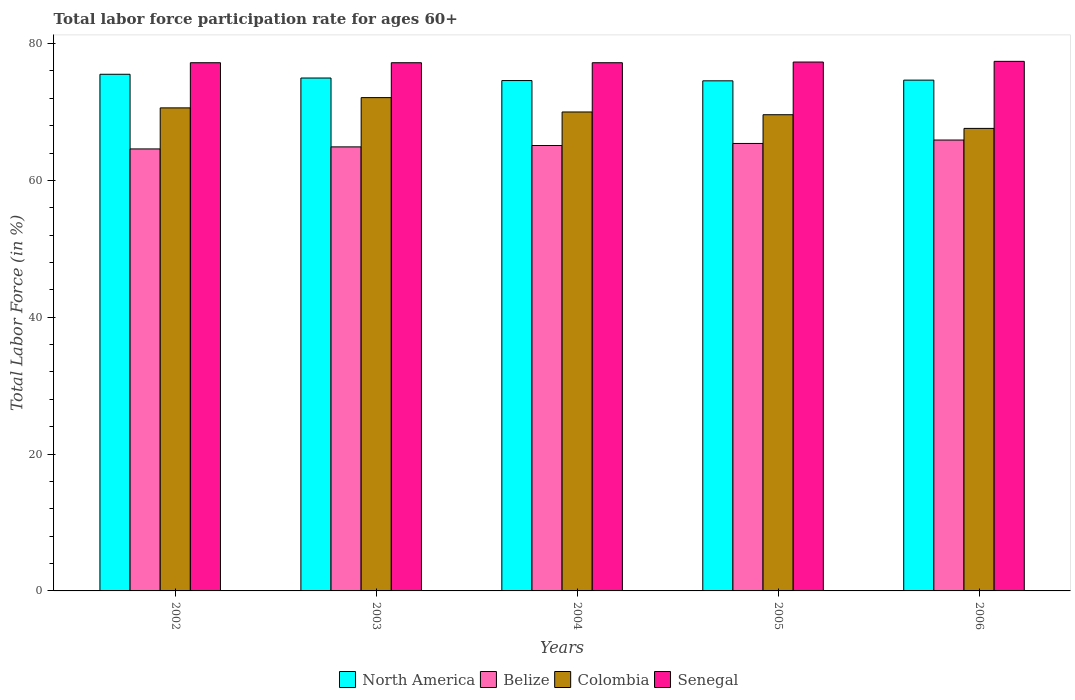How many groups of bars are there?
Your answer should be compact. 5. How many bars are there on the 4th tick from the right?
Make the answer very short. 4. What is the label of the 3rd group of bars from the left?
Give a very brief answer. 2004. What is the labor force participation rate in Senegal in 2002?
Your answer should be very brief. 77.2. Across all years, what is the maximum labor force participation rate in Colombia?
Provide a succinct answer. 72.1. Across all years, what is the minimum labor force participation rate in Colombia?
Offer a terse response. 67.6. What is the total labor force participation rate in Belize in the graph?
Your answer should be very brief. 325.9. What is the difference between the labor force participation rate in Colombia in 2003 and that in 2005?
Your answer should be compact. 2.5. What is the difference between the labor force participation rate in Belize in 2003 and the labor force participation rate in Senegal in 2005?
Your answer should be very brief. -12.4. What is the average labor force participation rate in Senegal per year?
Make the answer very short. 77.26. In the year 2003, what is the difference between the labor force participation rate in Belize and labor force participation rate in Senegal?
Make the answer very short. -12.3. What is the ratio of the labor force participation rate in Belize in 2002 to that in 2003?
Provide a short and direct response. 1. Is the difference between the labor force participation rate in Belize in 2003 and 2004 greater than the difference between the labor force participation rate in Senegal in 2003 and 2004?
Make the answer very short. No. What is the difference between the highest and the second highest labor force participation rate in Senegal?
Provide a short and direct response. 0.1. What is the difference between the highest and the lowest labor force participation rate in Senegal?
Your response must be concise. 0.2. What does the 3rd bar from the left in 2004 represents?
Provide a succinct answer. Colombia. How many bars are there?
Give a very brief answer. 20. How many years are there in the graph?
Give a very brief answer. 5. What is the difference between two consecutive major ticks on the Y-axis?
Ensure brevity in your answer.  20. Are the values on the major ticks of Y-axis written in scientific E-notation?
Offer a very short reply. No. Does the graph contain grids?
Give a very brief answer. No. Where does the legend appear in the graph?
Provide a short and direct response. Bottom center. How are the legend labels stacked?
Your answer should be compact. Horizontal. What is the title of the graph?
Your answer should be compact. Total labor force participation rate for ages 60+. Does "Malta" appear as one of the legend labels in the graph?
Make the answer very short. No. What is the label or title of the X-axis?
Offer a terse response. Years. What is the Total Labor Force (in %) of North America in 2002?
Ensure brevity in your answer.  75.51. What is the Total Labor Force (in %) in Belize in 2002?
Keep it short and to the point. 64.6. What is the Total Labor Force (in %) in Colombia in 2002?
Offer a very short reply. 70.6. What is the Total Labor Force (in %) of Senegal in 2002?
Keep it short and to the point. 77.2. What is the Total Labor Force (in %) of North America in 2003?
Offer a very short reply. 74.96. What is the Total Labor Force (in %) of Belize in 2003?
Your answer should be compact. 64.9. What is the Total Labor Force (in %) of Colombia in 2003?
Your answer should be very brief. 72.1. What is the Total Labor Force (in %) in Senegal in 2003?
Your answer should be very brief. 77.2. What is the Total Labor Force (in %) in North America in 2004?
Your response must be concise. 74.59. What is the Total Labor Force (in %) in Belize in 2004?
Offer a terse response. 65.1. What is the Total Labor Force (in %) in Senegal in 2004?
Make the answer very short. 77.2. What is the Total Labor Force (in %) in North America in 2005?
Make the answer very short. 74.55. What is the Total Labor Force (in %) in Belize in 2005?
Make the answer very short. 65.4. What is the Total Labor Force (in %) of Colombia in 2005?
Your response must be concise. 69.6. What is the Total Labor Force (in %) of Senegal in 2005?
Offer a terse response. 77.3. What is the Total Labor Force (in %) in North America in 2006?
Your response must be concise. 74.65. What is the Total Labor Force (in %) of Belize in 2006?
Ensure brevity in your answer.  65.9. What is the Total Labor Force (in %) in Colombia in 2006?
Offer a very short reply. 67.6. What is the Total Labor Force (in %) in Senegal in 2006?
Keep it short and to the point. 77.4. Across all years, what is the maximum Total Labor Force (in %) in North America?
Your response must be concise. 75.51. Across all years, what is the maximum Total Labor Force (in %) of Belize?
Provide a short and direct response. 65.9. Across all years, what is the maximum Total Labor Force (in %) in Colombia?
Give a very brief answer. 72.1. Across all years, what is the maximum Total Labor Force (in %) in Senegal?
Provide a succinct answer. 77.4. Across all years, what is the minimum Total Labor Force (in %) in North America?
Make the answer very short. 74.55. Across all years, what is the minimum Total Labor Force (in %) of Belize?
Your answer should be compact. 64.6. Across all years, what is the minimum Total Labor Force (in %) of Colombia?
Your answer should be very brief. 67.6. Across all years, what is the minimum Total Labor Force (in %) in Senegal?
Your answer should be compact. 77.2. What is the total Total Labor Force (in %) in North America in the graph?
Your answer should be compact. 374.28. What is the total Total Labor Force (in %) of Belize in the graph?
Provide a succinct answer. 325.9. What is the total Total Labor Force (in %) in Colombia in the graph?
Offer a terse response. 349.9. What is the total Total Labor Force (in %) of Senegal in the graph?
Your response must be concise. 386.3. What is the difference between the Total Labor Force (in %) of North America in 2002 and that in 2003?
Ensure brevity in your answer.  0.55. What is the difference between the Total Labor Force (in %) in Belize in 2002 and that in 2003?
Your answer should be compact. -0.3. What is the difference between the Total Labor Force (in %) in Senegal in 2002 and that in 2003?
Your answer should be compact. 0. What is the difference between the Total Labor Force (in %) in North America in 2002 and that in 2004?
Give a very brief answer. 0.92. What is the difference between the Total Labor Force (in %) of Colombia in 2002 and that in 2004?
Your answer should be very brief. 0.6. What is the difference between the Total Labor Force (in %) of Senegal in 2002 and that in 2004?
Provide a succinct answer. 0. What is the difference between the Total Labor Force (in %) of North America in 2002 and that in 2005?
Offer a very short reply. 0.96. What is the difference between the Total Labor Force (in %) of Belize in 2002 and that in 2005?
Give a very brief answer. -0.8. What is the difference between the Total Labor Force (in %) of Colombia in 2002 and that in 2005?
Ensure brevity in your answer.  1. What is the difference between the Total Labor Force (in %) in North America in 2002 and that in 2006?
Provide a succinct answer. 0.86. What is the difference between the Total Labor Force (in %) of Colombia in 2002 and that in 2006?
Make the answer very short. 3. What is the difference between the Total Labor Force (in %) in Senegal in 2002 and that in 2006?
Your answer should be very brief. -0.2. What is the difference between the Total Labor Force (in %) of North America in 2003 and that in 2004?
Offer a very short reply. 0.37. What is the difference between the Total Labor Force (in %) in Colombia in 2003 and that in 2004?
Your response must be concise. 2.1. What is the difference between the Total Labor Force (in %) of Senegal in 2003 and that in 2004?
Your response must be concise. 0. What is the difference between the Total Labor Force (in %) of North America in 2003 and that in 2005?
Provide a short and direct response. 0.41. What is the difference between the Total Labor Force (in %) of Belize in 2003 and that in 2005?
Your answer should be very brief. -0.5. What is the difference between the Total Labor Force (in %) in Colombia in 2003 and that in 2005?
Give a very brief answer. 2.5. What is the difference between the Total Labor Force (in %) in North America in 2003 and that in 2006?
Ensure brevity in your answer.  0.31. What is the difference between the Total Labor Force (in %) in Belize in 2003 and that in 2006?
Give a very brief answer. -1. What is the difference between the Total Labor Force (in %) in North America in 2004 and that in 2005?
Keep it short and to the point. 0.04. What is the difference between the Total Labor Force (in %) in North America in 2004 and that in 2006?
Your response must be concise. -0.06. What is the difference between the Total Labor Force (in %) of Belize in 2004 and that in 2006?
Your answer should be very brief. -0.8. What is the difference between the Total Labor Force (in %) of North America in 2005 and that in 2006?
Make the answer very short. -0.1. What is the difference between the Total Labor Force (in %) of Belize in 2005 and that in 2006?
Provide a succinct answer. -0.5. What is the difference between the Total Labor Force (in %) in North America in 2002 and the Total Labor Force (in %) in Belize in 2003?
Your answer should be very brief. 10.61. What is the difference between the Total Labor Force (in %) in North America in 2002 and the Total Labor Force (in %) in Colombia in 2003?
Your answer should be compact. 3.41. What is the difference between the Total Labor Force (in %) in North America in 2002 and the Total Labor Force (in %) in Senegal in 2003?
Your answer should be compact. -1.69. What is the difference between the Total Labor Force (in %) of Colombia in 2002 and the Total Labor Force (in %) of Senegal in 2003?
Give a very brief answer. -6.6. What is the difference between the Total Labor Force (in %) in North America in 2002 and the Total Labor Force (in %) in Belize in 2004?
Offer a very short reply. 10.41. What is the difference between the Total Labor Force (in %) of North America in 2002 and the Total Labor Force (in %) of Colombia in 2004?
Make the answer very short. 5.51. What is the difference between the Total Labor Force (in %) in North America in 2002 and the Total Labor Force (in %) in Senegal in 2004?
Keep it short and to the point. -1.69. What is the difference between the Total Labor Force (in %) in North America in 2002 and the Total Labor Force (in %) in Belize in 2005?
Offer a very short reply. 10.11. What is the difference between the Total Labor Force (in %) in North America in 2002 and the Total Labor Force (in %) in Colombia in 2005?
Ensure brevity in your answer.  5.91. What is the difference between the Total Labor Force (in %) in North America in 2002 and the Total Labor Force (in %) in Senegal in 2005?
Your response must be concise. -1.79. What is the difference between the Total Labor Force (in %) of Belize in 2002 and the Total Labor Force (in %) of Colombia in 2005?
Keep it short and to the point. -5. What is the difference between the Total Labor Force (in %) in Belize in 2002 and the Total Labor Force (in %) in Senegal in 2005?
Offer a very short reply. -12.7. What is the difference between the Total Labor Force (in %) of Colombia in 2002 and the Total Labor Force (in %) of Senegal in 2005?
Provide a succinct answer. -6.7. What is the difference between the Total Labor Force (in %) in North America in 2002 and the Total Labor Force (in %) in Belize in 2006?
Your answer should be compact. 9.61. What is the difference between the Total Labor Force (in %) of North America in 2002 and the Total Labor Force (in %) of Colombia in 2006?
Ensure brevity in your answer.  7.91. What is the difference between the Total Labor Force (in %) in North America in 2002 and the Total Labor Force (in %) in Senegal in 2006?
Your answer should be compact. -1.89. What is the difference between the Total Labor Force (in %) of Belize in 2002 and the Total Labor Force (in %) of Colombia in 2006?
Your response must be concise. -3. What is the difference between the Total Labor Force (in %) of Belize in 2002 and the Total Labor Force (in %) of Senegal in 2006?
Offer a terse response. -12.8. What is the difference between the Total Labor Force (in %) of North America in 2003 and the Total Labor Force (in %) of Belize in 2004?
Ensure brevity in your answer.  9.86. What is the difference between the Total Labor Force (in %) in North America in 2003 and the Total Labor Force (in %) in Colombia in 2004?
Offer a very short reply. 4.96. What is the difference between the Total Labor Force (in %) of North America in 2003 and the Total Labor Force (in %) of Senegal in 2004?
Keep it short and to the point. -2.24. What is the difference between the Total Labor Force (in %) in Belize in 2003 and the Total Labor Force (in %) in Colombia in 2004?
Give a very brief answer. -5.1. What is the difference between the Total Labor Force (in %) of Colombia in 2003 and the Total Labor Force (in %) of Senegal in 2004?
Ensure brevity in your answer.  -5.1. What is the difference between the Total Labor Force (in %) of North America in 2003 and the Total Labor Force (in %) of Belize in 2005?
Provide a succinct answer. 9.56. What is the difference between the Total Labor Force (in %) of North America in 2003 and the Total Labor Force (in %) of Colombia in 2005?
Your answer should be very brief. 5.36. What is the difference between the Total Labor Force (in %) in North America in 2003 and the Total Labor Force (in %) in Senegal in 2005?
Your answer should be very brief. -2.34. What is the difference between the Total Labor Force (in %) in Belize in 2003 and the Total Labor Force (in %) in Colombia in 2005?
Offer a terse response. -4.7. What is the difference between the Total Labor Force (in %) in Colombia in 2003 and the Total Labor Force (in %) in Senegal in 2005?
Give a very brief answer. -5.2. What is the difference between the Total Labor Force (in %) of North America in 2003 and the Total Labor Force (in %) of Belize in 2006?
Keep it short and to the point. 9.06. What is the difference between the Total Labor Force (in %) of North America in 2003 and the Total Labor Force (in %) of Colombia in 2006?
Make the answer very short. 7.36. What is the difference between the Total Labor Force (in %) in North America in 2003 and the Total Labor Force (in %) in Senegal in 2006?
Give a very brief answer. -2.44. What is the difference between the Total Labor Force (in %) in Belize in 2003 and the Total Labor Force (in %) in Colombia in 2006?
Offer a very short reply. -2.7. What is the difference between the Total Labor Force (in %) in Belize in 2003 and the Total Labor Force (in %) in Senegal in 2006?
Your answer should be very brief. -12.5. What is the difference between the Total Labor Force (in %) in North America in 2004 and the Total Labor Force (in %) in Belize in 2005?
Offer a terse response. 9.19. What is the difference between the Total Labor Force (in %) of North America in 2004 and the Total Labor Force (in %) of Colombia in 2005?
Keep it short and to the point. 4.99. What is the difference between the Total Labor Force (in %) of North America in 2004 and the Total Labor Force (in %) of Senegal in 2005?
Make the answer very short. -2.71. What is the difference between the Total Labor Force (in %) of Belize in 2004 and the Total Labor Force (in %) of Colombia in 2005?
Offer a terse response. -4.5. What is the difference between the Total Labor Force (in %) in Colombia in 2004 and the Total Labor Force (in %) in Senegal in 2005?
Offer a very short reply. -7.3. What is the difference between the Total Labor Force (in %) in North America in 2004 and the Total Labor Force (in %) in Belize in 2006?
Keep it short and to the point. 8.69. What is the difference between the Total Labor Force (in %) of North America in 2004 and the Total Labor Force (in %) of Colombia in 2006?
Give a very brief answer. 6.99. What is the difference between the Total Labor Force (in %) of North America in 2004 and the Total Labor Force (in %) of Senegal in 2006?
Give a very brief answer. -2.81. What is the difference between the Total Labor Force (in %) of Belize in 2004 and the Total Labor Force (in %) of Senegal in 2006?
Ensure brevity in your answer.  -12.3. What is the difference between the Total Labor Force (in %) of Colombia in 2004 and the Total Labor Force (in %) of Senegal in 2006?
Ensure brevity in your answer.  -7.4. What is the difference between the Total Labor Force (in %) of North America in 2005 and the Total Labor Force (in %) of Belize in 2006?
Give a very brief answer. 8.65. What is the difference between the Total Labor Force (in %) of North America in 2005 and the Total Labor Force (in %) of Colombia in 2006?
Make the answer very short. 6.95. What is the difference between the Total Labor Force (in %) of North America in 2005 and the Total Labor Force (in %) of Senegal in 2006?
Your answer should be very brief. -2.85. What is the difference between the Total Labor Force (in %) of Belize in 2005 and the Total Labor Force (in %) of Colombia in 2006?
Make the answer very short. -2.2. What is the difference between the Total Labor Force (in %) in Belize in 2005 and the Total Labor Force (in %) in Senegal in 2006?
Offer a very short reply. -12. What is the average Total Labor Force (in %) of North America per year?
Provide a succinct answer. 74.86. What is the average Total Labor Force (in %) in Belize per year?
Offer a very short reply. 65.18. What is the average Total Labor Force (in %) in Colombia per year?
Provide a succinct answer. 69.98. What is the average Total Labor Force (in %) in Senegal per year?
Ensure brevity in your answer.  77.26. In the year 2002, what is the difference between the Total Labor Force (in %) in North America and Total Labor Force (in %) in Belize?
Make the answer very short. 10.91. In the year 2002, what is the difference between the Total Labor Force (in %) in North America and Total Labor Force (in %) in Colombia?
Provide a short and direct response. 4.91. In the year 2002, what is the difference between the Total Labor Force (in %) in North America and Total Labor Force (in %) in Senegal?
Offer a terse response. -1.69. In the year 2003, what is the difference between the Total Labor Force (in %) in North America and Total Labor Force (in %) in Belize?
Give a very brief answer. 10.06. In the year 2003, what is the difference between the Total Labor Force (in %) in North America and Total Labor Force (in %) in Colombia?
Offer a very short reply. 2.86. In the year 2003, what is the difference between the Total Labor Force (in %) in North America and Total Labor Force (in %) in Senegal?
Offer a terse response. -2.24. In the year 2003, what is the difference between the Total Labor Force (in %) in Belize and Total Labor Force (in %) in Colombia?
Ensure brevity in your answer.  -7.2. In the year 2004, what is the difference between the Total Labor Force (in %) of North America and Total Labor Force (in %) of Belize?
Provide a short and direct response. 9.49. In the year 2004, what is the difference between the Total Labor Force (in %) of North America and Total Labor Force (in %) of Colombia?
Offer a very short reply. 4.59. In the year 2004, what is the difference between the Total Labor Force (in %) in North America and Total Labor Force (in %) in Senegal?
Offer a very short reply. -2.61. In the year 2004, what is the difference between the Total Labor Force (in %) in Belize and Total Labor Force (in %) in Colombia?
Ensure brevity in your answer.  -4.9. In the year 2004, what is the difference between the Total Labor Force (in %) of Belize and Total Labor Force (in %) of Senegal?
Offer a very short reply. -12.1. In the year 2005, what is the difference between the Total Labor Force (in %) in North America and Total Labor Force (in %) in Belize?
Your answer should be very brief. 9.15. In the year 2005, what is the difference between the Total Labor Force (in %) in North America and Total Labor Force (in %) in Colombia?
Keep it short and to the point. 4.95. In the year 2005, what is the difference between the Total Labor Force (in %) in North America and Total Labor Force (in %) in Senegal?
Offer a terse response. -2.75. In the year 2005, what is the difference between the Total Labor Force (in %) in Belize and Total Labor Force (in %) in Senegal?
Make the answer very short. -11.9. In the year 2005, what is the difference between the Total Labor Force (in %) of Colombia and Total Labor Force (in %) of Senegal?
Your response must be concise. -7.7. In the year 2006, what is the difference between the Total Labor Force (in %) in North America and Total Labor Force (in %) in Belize?
Your answer should be compact. 8.75. In the year 2006, what is the difference between the Total Labor Force (in %) of North America and Total Labor Force (in %) of Colombia?
Offer a very short reply. 7.05. In the year 2006, what is the difference between the Total Labor Force (in %) of North America and Total Labor Force (in %) of Senegal?
Make the answer very short. -2.75. In the year 2006, what is the difference between the Total Labor Force (in %) of Belize and Total Labor Force (in %) of Colombia?
Offer a very short reply. -1.7. In the year 2006, what is the difference between the Total Labor Force (in %) in Belize and Total Labor Force (in %) in Senegal?
Offer a terse response. -11.5. In the year 2006, what is the difference between the Total Labor Force (in %) in Colombia and Total Labor Force (in %) in Senegal?
Offer a terse response. -9.8. What is the ratio of the Total Labor Force (in %) of North America in 2002 to that in 2003?
Keep it short and to the point. 1.01. What is the ratio of the Total Labor Force (in %) of Belize in 2002 to that in 2003?
Offer a terse response. 1. What is the ratio of the Total Labor Force (in %) of Colombia in 2002 to that in 2003?
Offer a terse response. 0.98. What is the ratio of the Total Labor Force (in %) in Senegal in 2002 to that in 2003?
Offer a terse response. 1. What is the ratio of the Total Labor Force (in %) in North America in 2002 to that in 2004?
Your response must be concise. 1.01. What is the ratio of the Total Labor Force (in %) in Colombia in 2002 to that in 2004?
Your response must be concise. 1.01. What is the ratio of the Total Labor Force (in %) of North America in 2002 to that in 2005?
Make the answer very short. 1.01. What is the ratio of the Total Labor Force (in %) of Belize in 2002 to that in 2005?
Provide a succinct answer. 0.99. What is the ratio of the Total Labor Force (in %) in Colombia in 2002 to that in 2005?
Provide a succinct answer. 1.01. What is the ratio of the Total Labor Force (in %) in Senegal in 2002 to that in 2005?
Your response must be concise. 1. What is the ratio of the Total Labor Force (in %) in North America in 2002 to that in 2006?
Keep it short and to the point. 1.01. What is the ratio of the Total Labor Force (in %) of Belize in 2002 to that in 2006?
Make the answer very short. 0.98. What is the ratio of the Total Labor Force (in %) in Colombia in 2002 to that in 2006?
Your answer should be very brief. 1.04. What is the ratio of the Total Labor Force (in %) of Colombia in 2003 to that in 2004?
Offer a terse response. 1.03. What is the ratio of the Total Labor Force (in %) in Senegal in 2003 to that in 2004?
Provide a succinct answer. 1. What is the ratio of the Total Labor Force (in %) in Belize in 2003 to that in 2005?
Ensure brevity in your answer.  0.99. What is the ratio of the Total Labor Force (in %) of Colombia in 2003 to that in 2005?
Your answer should be very brief. 1.04. What is the ratio of the Total Labor Force (in %) of Senegal in 2003 to that in 2005?
Offer a very short reply. 1. What is the ratio of the Total Labor Force (in %) of North America in 2003 to that in 2006?
Keep it short and to the point. 1. What is the ratio of the Total Labor Force (in %) in Belize in 2003 to that in 2006?
Offer a terse response. 0.98. What is the ratio of the Total Labor Force (in %) in Colombia in 2003 to that in 2006?
Your response must be concise. 1.07. What is the ratio of the Total Labor Force (in %) of Senegal in 2003 to that in 2006?
Offer a very short reply. 1. What is the ratio of the Total Labor Force (in %) of Colombia in 2004 to that in 2005?
Give a very brief answer. 1.01. What is the ratio of the Total Labor Force (in %) in Senegal in 2004 to that in 2005?
Your response must be concise. 1. What is the ratio of the Total Labor Force (in %) of North America in 2004 to that in 2006?
Your answer should be compact. 1. What is the ratio of the Total Labor Force (in %) in Belize in 2004 to that in 2006?
Offer a very short reply. 0.99. What is the ratio of the Total Labor Force (in %) in Colombia in 2004 to that in 2006?
Provide a succinct answer. 1.04. What is the ratio of the Total Labor Force (in %) of Senegal in 2004 to that in 2006?
Offer a very short reply. 1. What is the ratio of the Total Labor Force (in %) of Belize in 2005 to that in 2006?
Your response must be concise. 0.99. What is the ratio of the Total Labor Force (in %) of Colombia in 2005 to that in 2006?
Offer a very short reply. 1.03. What is the difference between the highest and the second highest Total Labor Force (in %) of North America?
Offer a very short reply. 0.55. What is the difference between the highest and the second highest Total Labor Force (in %) in Colombia?
Your answer should be compact. 1.5. What is the difference between the highest and the lowest Total Labor Force (in %) of North America?
Make the answer very short. 0.96. What is the difference between the highest and the lowest Total Labor Force (in %) in Belize?
Your answer should be compact. 1.3. What is the difference between the highest and the lowest Total Labor Force (in %) of Senegal?
Make the answer very short. 0.2. 